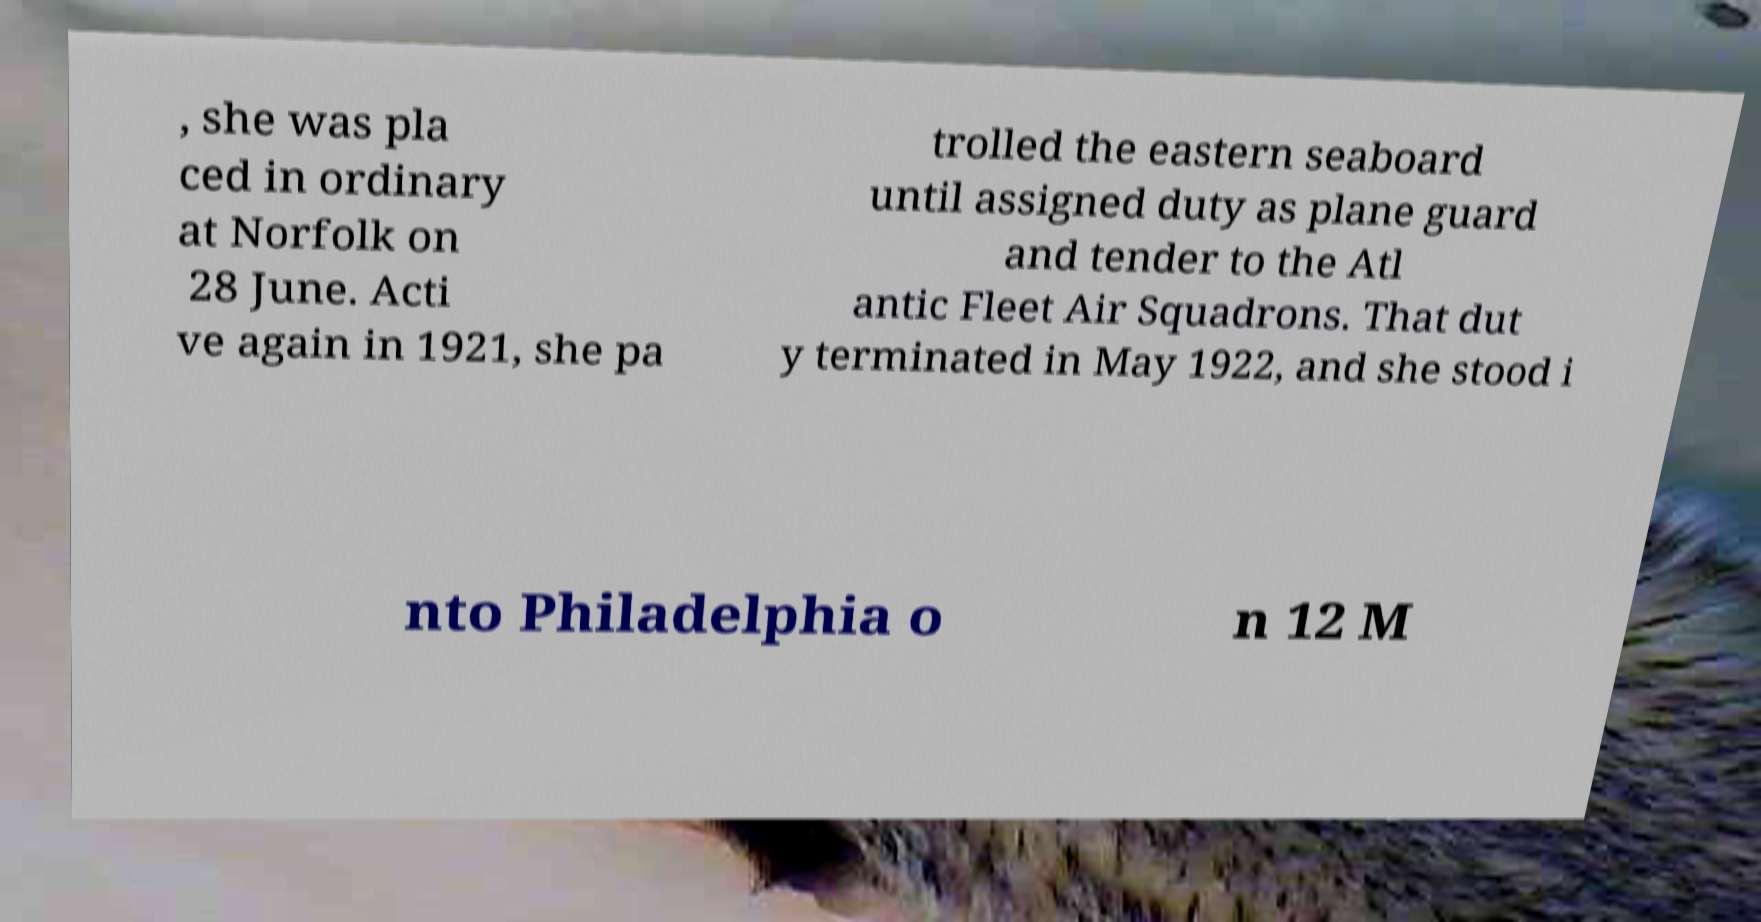Could you extract and type out the text from this image? , she was pla ced in ordinary at Norfolk on 28 June. Acti ve again in 1921, she pa trolled the eastern seaboard until assigned duty as plane guard and tender to the Atl antic Fleet Air Squadrons. That dut y terminated in May 1922, and she stood i nto Philadelphia o n 12 M 